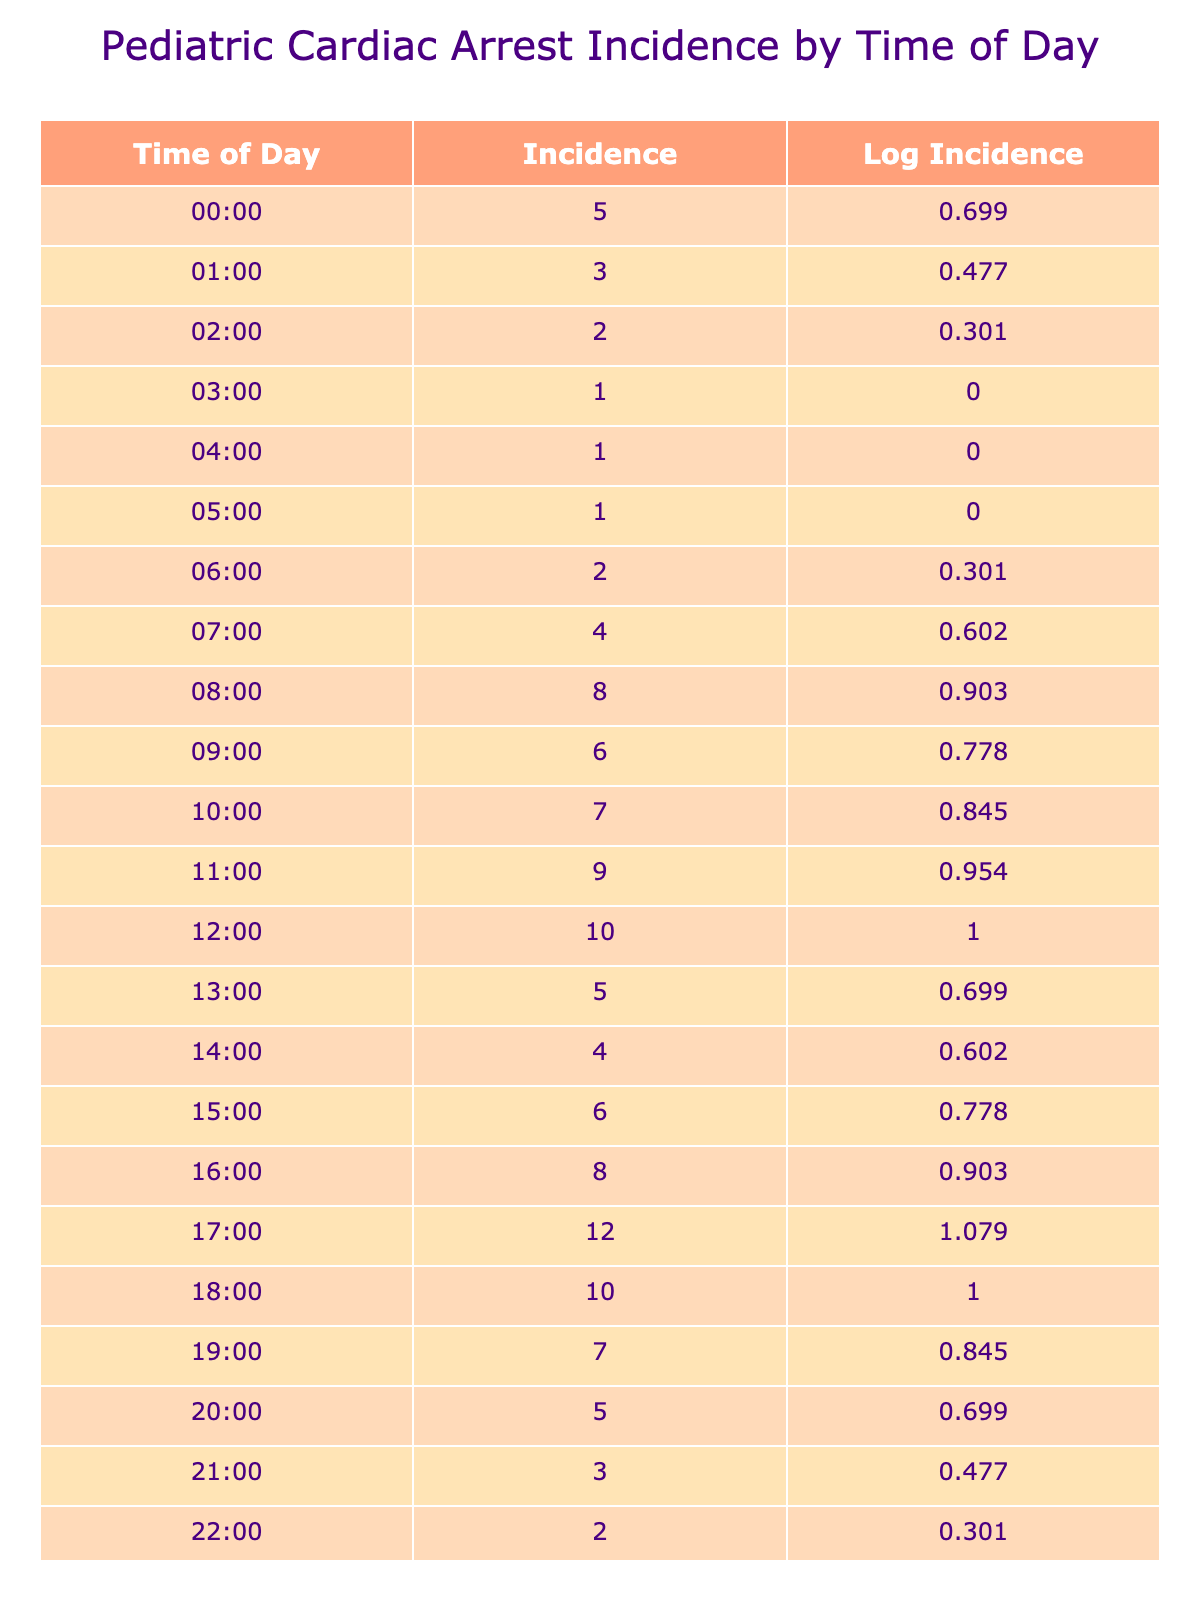What is the highest incidence of pediatric cardiac arrest recorded in the table? By checking the 'Incidence of Pediatric Cardiac Arrest' column, the highest value listed is 12, which occurs at 17:00.
Answer: 12 At what time of day is the incidence of pediatric cardiac arrest the lowest? The lowest value in the 'Incidence of Pediatric Cardiac Arrest' column is 1, found at 03:00, 04:00, and 05:00.
Answer: 03:00, 04:00, 05:00 What is the average incidence of pediatric cardiac arrest between 12:00 and 18:00? To find the average, sum the incidences from 12:00 (10), 13:00 (5), 14:00 (4), 15:00 (6), 16:00 (8), 17:00 (12), and 18:00 (10) which equals 55. Then, divide by 6 (the number of time points), giving 55/6 = approximately 9.17.
Answer: 9.17 Is the incidence at 08:00 higher than at 21:00? The incidence at 08:00 is 8 and at 21:00 it is 3. Since 8 is greater than 3, the statement is true.
Answer: Yes What time intervals show an increase in the incidence of pediatric cardiac arrest? By analyzing the incidences at 7:00 (4), 8:00 (8), and 9:00 (6), there is an increase from 7:00 to 8:00. Then from 15:00 (6) to 16:00 (8) and 16:00 to 17:00 (12), we see increases as well.
Answer: 7:00 to 8:00, 15:00 to 16:00, 16:00 to 17:00 What is the total incidence of pediatric cardiac arrest between 00:00 and 11:00? To calculate the total, sum the incidences from each hour: 5 + 3 + 2 + 1 + 1 + 1 + 2 + 4 + 8 + 6 + 7 + 9 = 49.
Answer: 49 How many times did the incidence of cardiac arrest reach 4 or more before noon? The values that meet this criterion before noon are from 08:00 (8), 09:00 (6), 10:00 (7), and 11:00 (9), totaling 4 instances.
Answer: 4 What is the difference in incidence between 18:00 and 12:00? The incidence at 18:00 is 10 and at 12:00 is 10 too. The difference is calculated as 10 - 10 = 0.
Answer: 0 